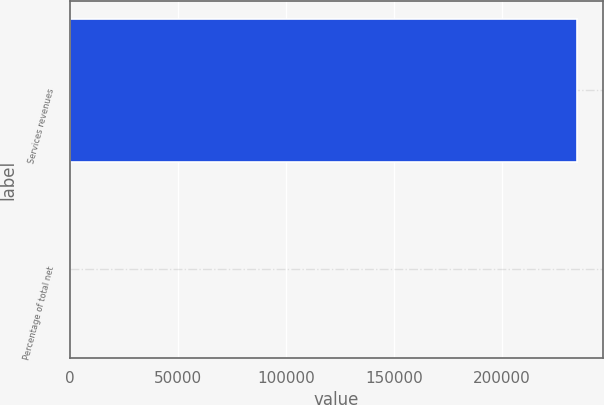<chart> <loc_0><loc_0><loc_500><loc_500><bar_chart><fcel>Services revenues<fcel>Percentage of total net<nl><fcel>234738<fcel>5<nl></chart> 